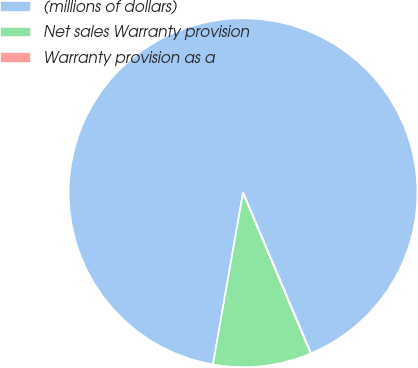Convert chart. <chart><loc_0><loc_0><loc_500><loc_500><pie_chart><fcel>(millions of dollars)<fcel>Net sales Warranty provision<fcel>Warranty provision as a<nl><fcel>90.87%<fcel>9.11%<fcel>0.02%<nl></chart> 